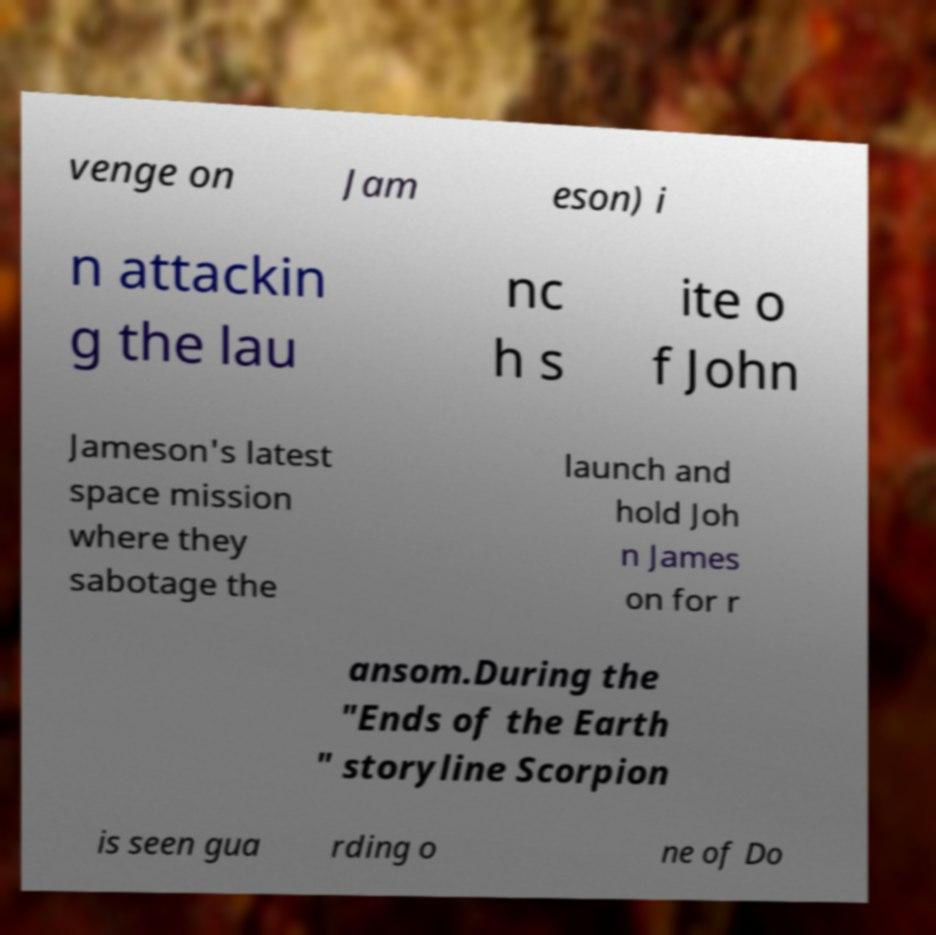I need the written content from this picture converted into text. Can you do that? venge on Jam eson) i n attackin g the lau nc h s ite o f John Jameson's latest space mission where they sabotage the launch and hold Joh n James on for r ansom.During the "Ends of the Earth " storyline Scorpion is seen gua rding o ne of Do 